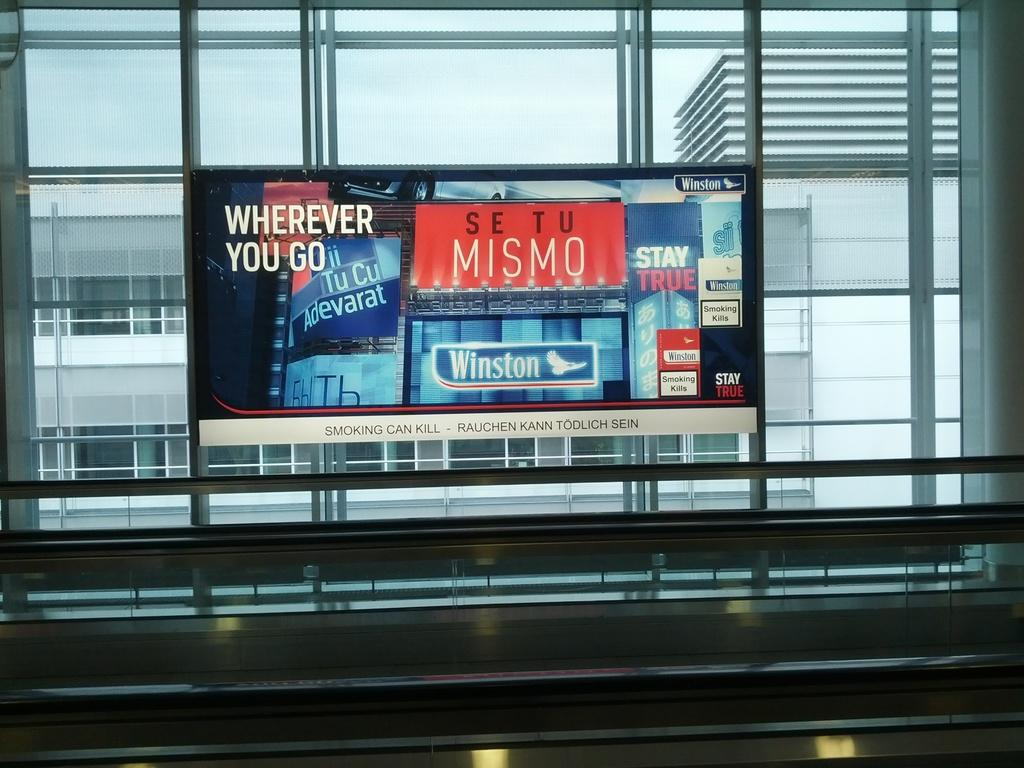<image>
Render a clear and concise summary of the photo. An ad for Winston advises that Smoking Can Kill. 